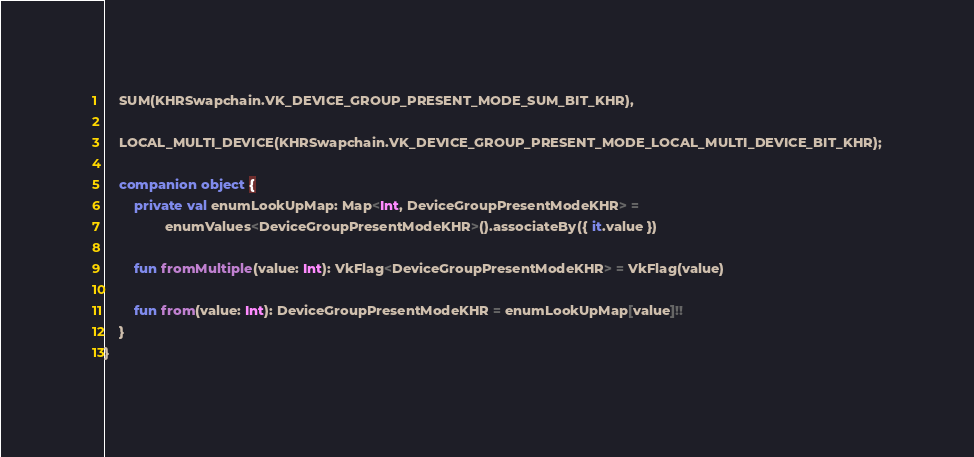Convert code to text. <code><loc_0><loc_0><loc_500><loc_500><_Kotlin_>	SUM(KHRSwapchain.VK_DEVICE_GROUP_PRESENT_MODE_SUM_BIT_KHR),

	LOCAL_MULTI_DEVICE(KHRSwapchain.VK_DEVICE_GROUP_PRESENT_MODE_LOCAL_MULTI_DEVICE_BIT_KHR);

	companion object {
		private val enumLookUpMap: Map<Int, DeviceGroupPresentModeKHR> =
				enumValues<DeviceGroupPresentModeKHR>().associateBy({ it.value })

		fun fromMultiple(value: Int): VkFlag<DeviceGroupPresentModeKHR> = VkFlag(value)

		fun from(value: Int): DeviceGroupPresentModeKHR = enumLookUpMap[value]!!
	}
}

</code> 